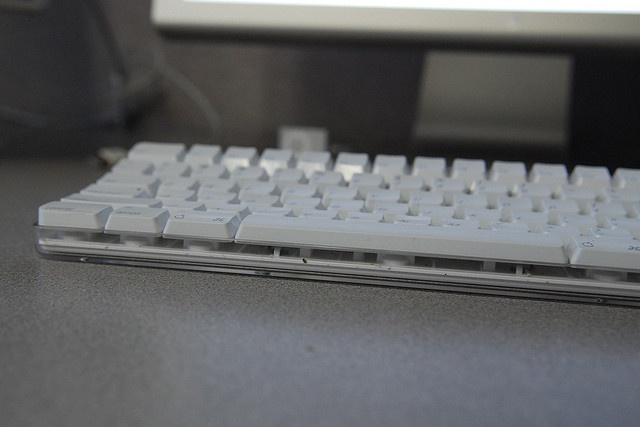Describe the objects in this image and their specific colors. I can see keyboard in black, darkgray, and gray tones and tv in black, darkgray, gray, and lightgray tones in this image. 